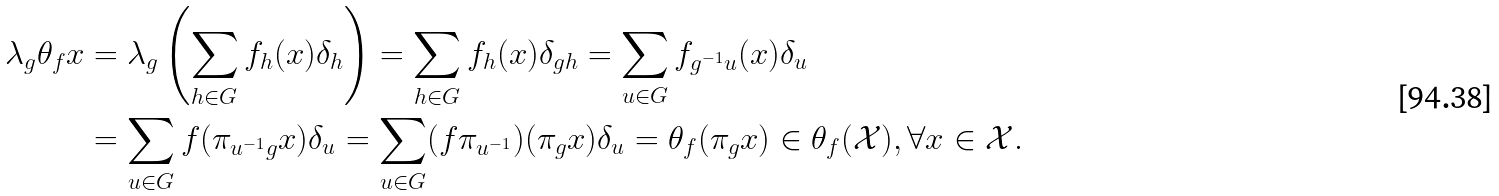<formula> <loc_0><loc_0><loc_500><loc_500>\lambda _ { g } \theta _ { f } x & = \lambda _ { g } \left ( \sum _ { h \in G } f _ { h } ( x ) \delta _ { h } \right ) = \sum _ { h \in G } f _ { h } ( x ) \delta _ { g h } = \sum _ { u \in G } f _ { g ^ { - 1 } u } ( x ) \delta _ { u } \\ & = \sum _ { u \in G } f ( \pi _ { u ^ { - 1 } g } x ) \delta _ { u } = \sum _ { u \in G } ( f \pi _ { u ^ { - 1 } } ) ( \pi _ { g } x ) \delta _ { u } = \theta _ { f } ( \pi _ { g } x ) \in \theta _ { f } ( \mathcal { X } ) , \forall x \in \mathcal { X } .</formula> 